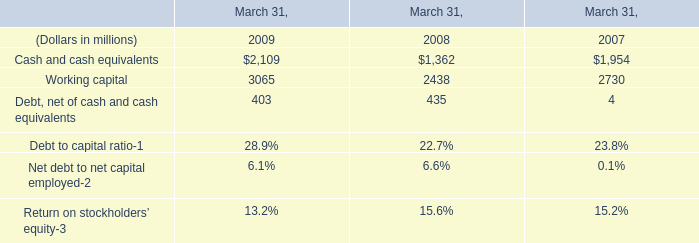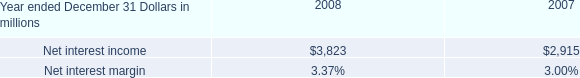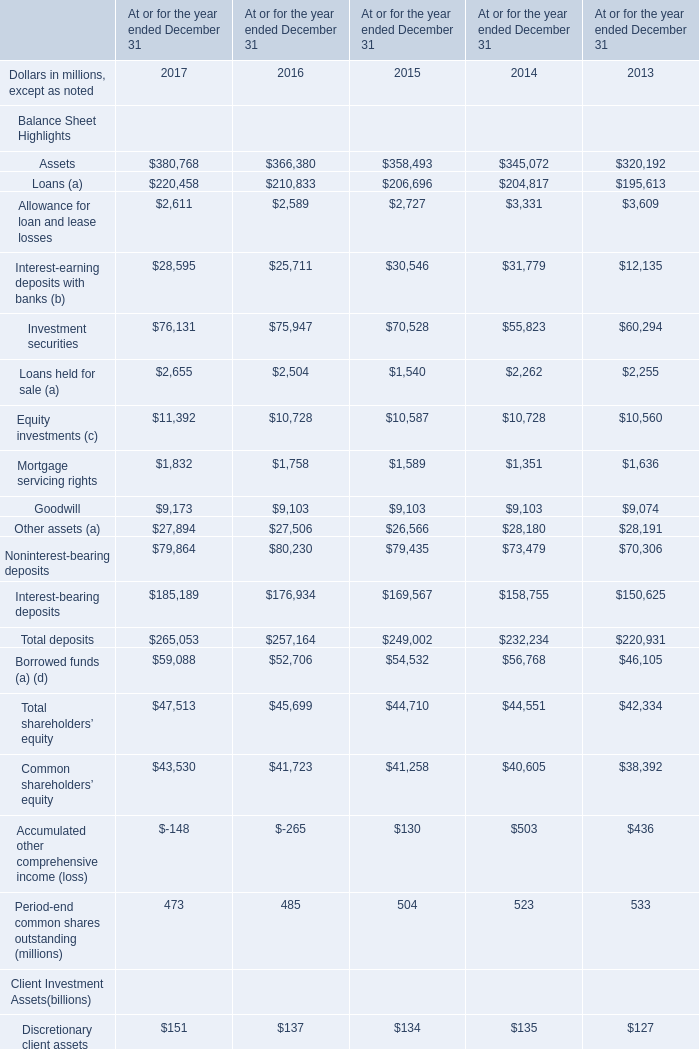what was the average net interest margin for 2008 and for 2007? 
Computations: ((3.37 + 3.00) / 2)
Answer: 3.185. 